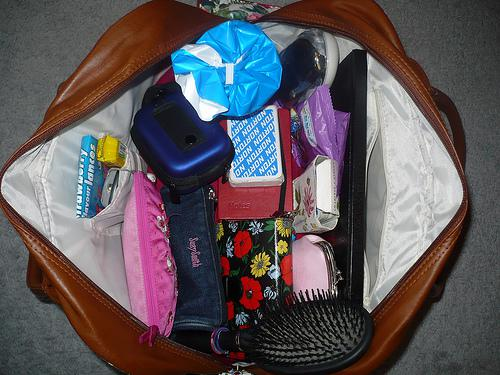Question: how many bags are in the picture?
Choices:
A. Two.
B. One.
C. Five.
D. Six.
Answer with the letter. Answer: B Question: what is brown?
Choices:
A. The purse.
B. The bag.
C. The suitcase.
D. The cat.
Answer with the letter. Answer: B Question: where is a hairbrush?
Choices:
A. In the suitcase.
B. In the box.
C. On the ground.
D. In the brown bag.
Answer with the letter. Answer: D 